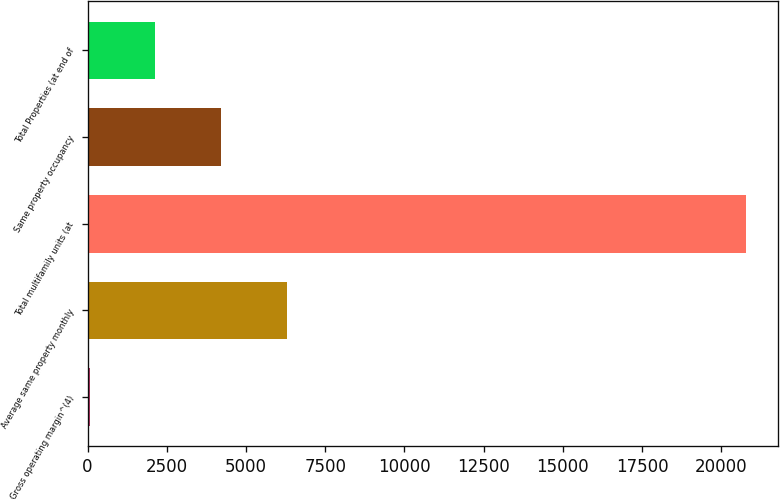Convert chart to OTSL. <chart><loc_0><loc_0><loc_500><loc_500><bar_chart><fcel>Gross operating margin^(4)<fcel>Average same property monthly<fcel>Total multifamily units (at<fcel>Same property occupancy<fcel>Total Properties (at end of<nl><fcel>71<fcel>6278.3<fcel>20762<fcel>4209.2<fcel>2140.1<nl></chart> 